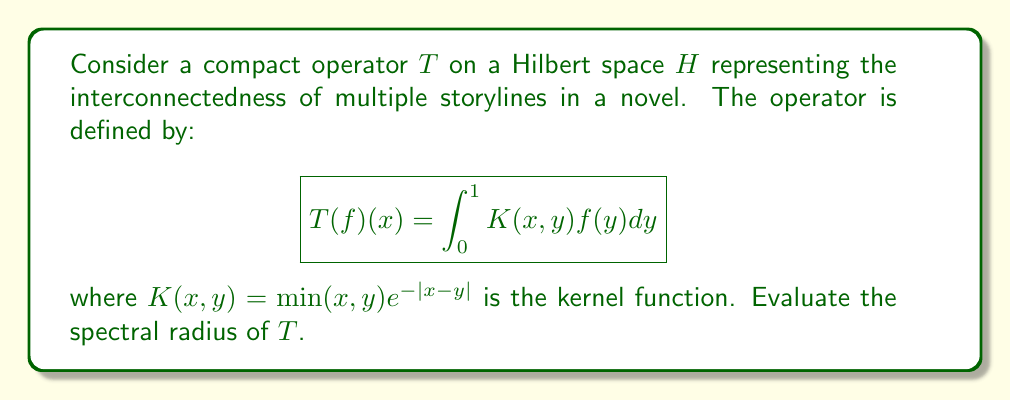Solve this math problem. To evaluate the spectral radius of the compact operator $T$, we'll follow these steps:

1) For a compact operator on a Hilbert space, the spectral radius is equal to the largest eigenvalue in absolute value.

2) The eigenvalue equation for $T$ is:

   $$\lambda f(x) = \int_0^1 \min(x,y)e^{-|x-y|}f(y)dy$$

3) Differentiating both sides twice with respect to $x$:

   $$\lambda f''(x) = f(x) - 2f'(x)$$

4) This is a second-order differential equation. The general solution is:

   $$f(x) = c_1e^{r_1x} + c_2e^{r_2x}$$

   where $r_1$ and $r_2$ are roots of the characteristic equation:

   $$\lambda r^2 = 1 - 2r$$

5) Solving this equation:

   $$r = \frac{1 \pm \sqrt{1 + \lambda}}{\lambda}$$

6) For the solution to be non-trivial and satisfy the boundary conditions, we must have:

   $$\frac{1 + \sqrt{1 + \lambda}}{\lambda} = 1$$

7) Solving this equation:

   $$\lambda = \frac{4}{n^2\pi^2}$$

   for $n = 1, 2, 3, ...$

8) The largest eigenvalue (in absolute value) occurs when $n = 1$:

   $$\lambda_{\max} = \frac{4}{\pi^2}$$

9) Therefore, the spectral radius of $T$ is $\frac{4}{\pi^2}$.

This result shows that the interconnectedness of storylines has a maximum "strength" represented by this spectral radius, which could be interpreted as the upper limit of how tightly different narrative threads can be woven together in the story structure.
Answer: The spectral radius of the compact operator $T$ is $\frac{4}{\pi^2}$. 